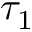<formula> <loc_0><loc_0><loc_500><loc_500>\tau _ { 1 }</formula> 